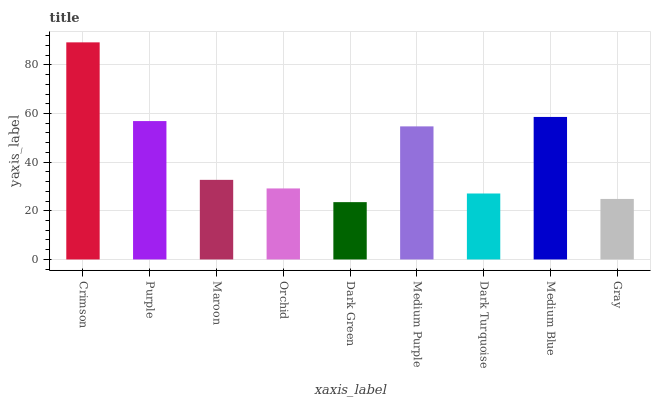Is Dark Green the minimum?
Answer yes or no. Yes. Is Crimson the maximum?
Answer yes or no. Yes. Is Purple the minimum?
Answer yes or no. No. Is Purple the maximum?
Answer yes or no. No. Is Crimson greater than Purple?
Answer yes or no. Yes. Is Purple less than Crimson?
Answer yes or no. Yes. Is Purple greater than Crimson?
Answer yes or no. No. Is Crimson less than Purple?
Answer yes or no. No. Is Maroon the high median?
Answer yes or no. Yes. Is Maroon the low median?
Answer yes or no. Yes. Is Crimson the high median?
Answer yes or no. No. Is Dark Turquoise the low median?
Answer yes or no. No. 